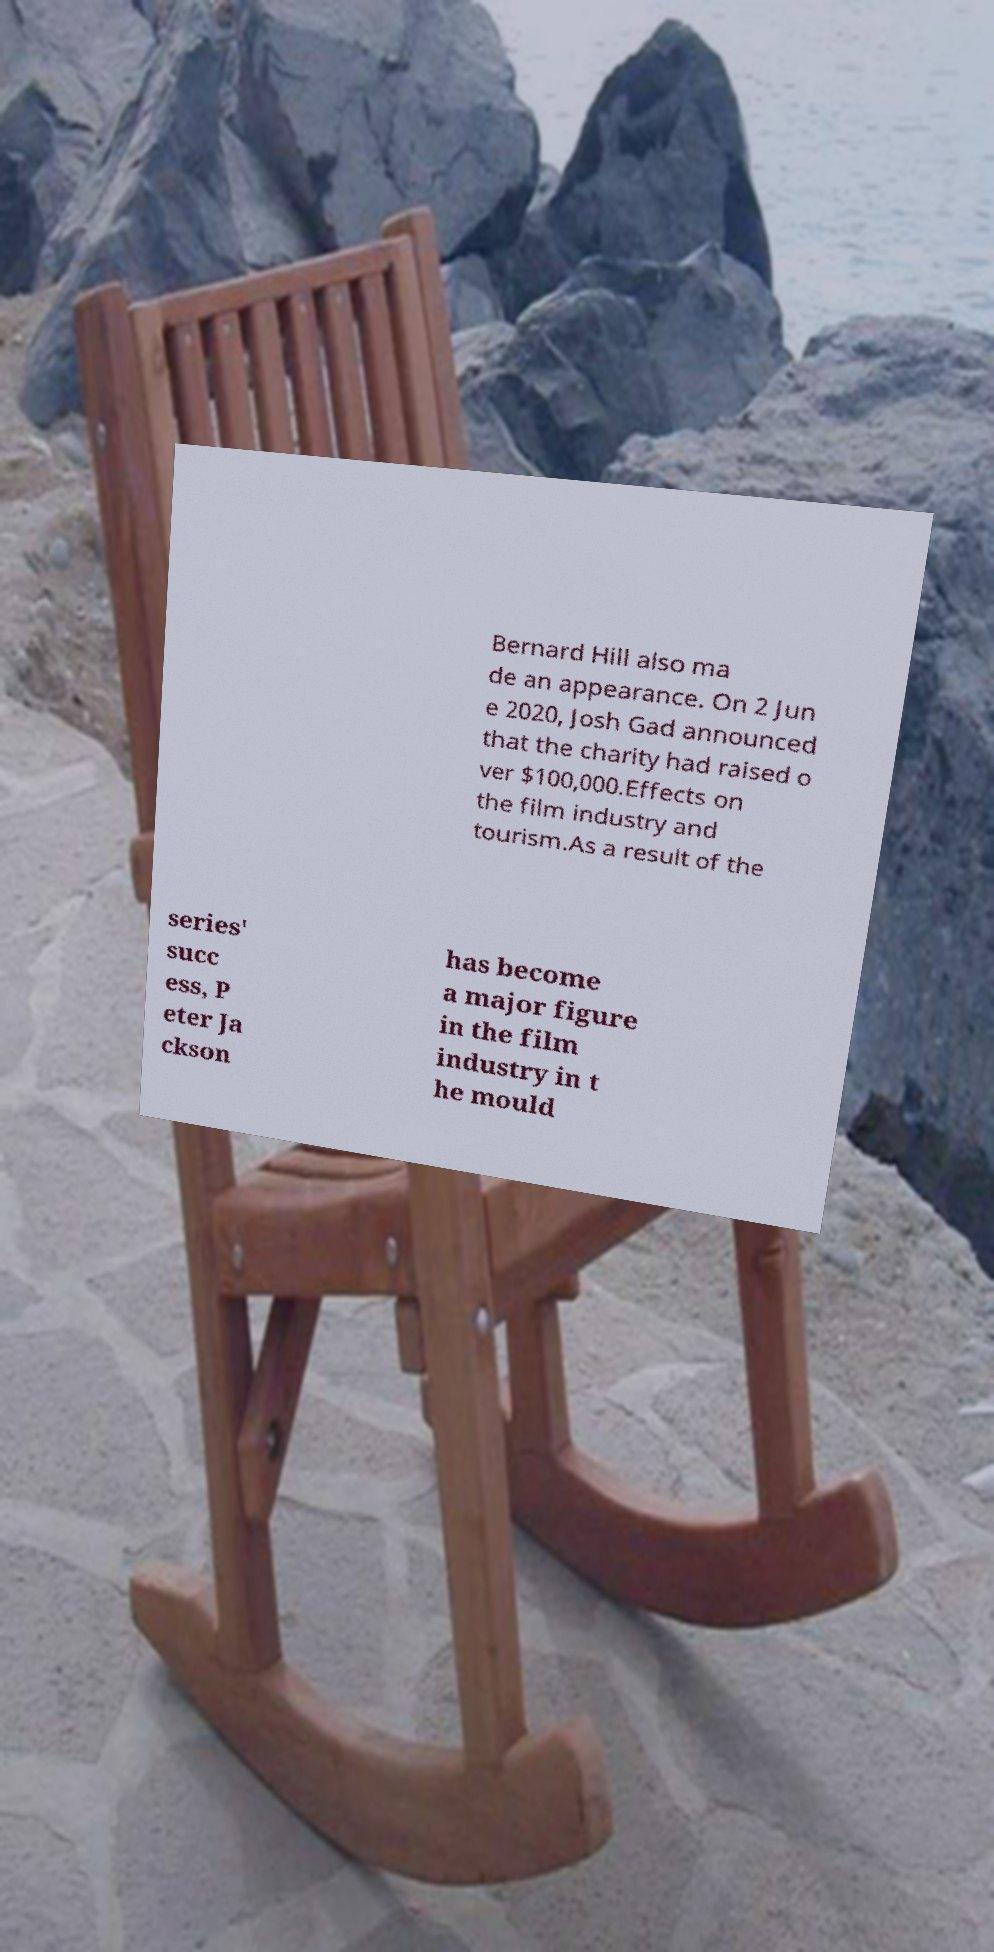Can you accurately transcribe the text from the provided image for me? Bernard Hill also ma de an appearance. On 2 Jun e 2020, Josh Gad announced that the charity had raised o ver $100,000.Effects on the film industry and tourism.As a result of the series' succ ess, P eter Ja ckson has become a major figure in the film industry in t he mould 